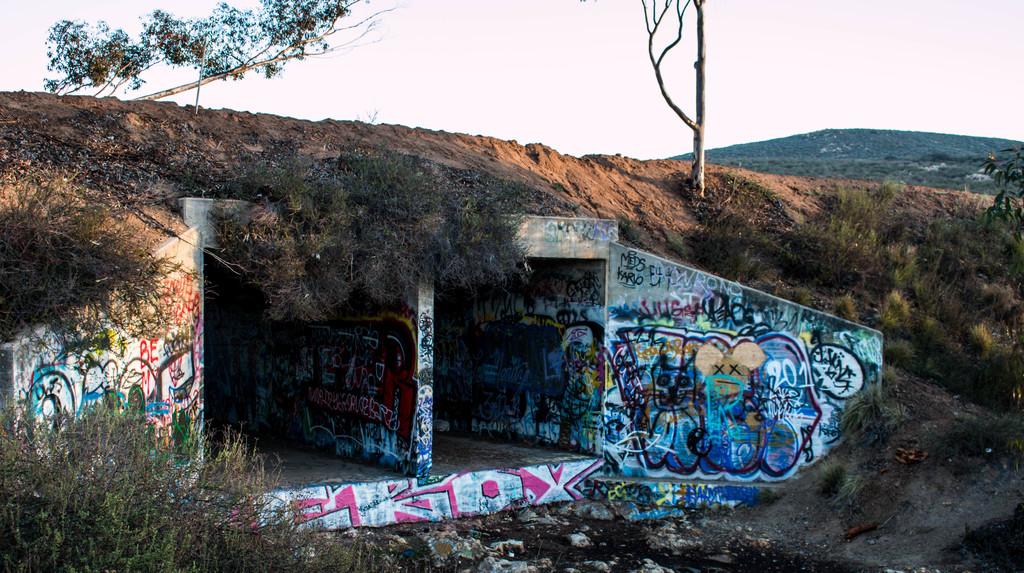What year is on the right hand side wall?
Ensure brevity in your answer.  2013. What word is written in red?
Your answer should be very brief. Be. 